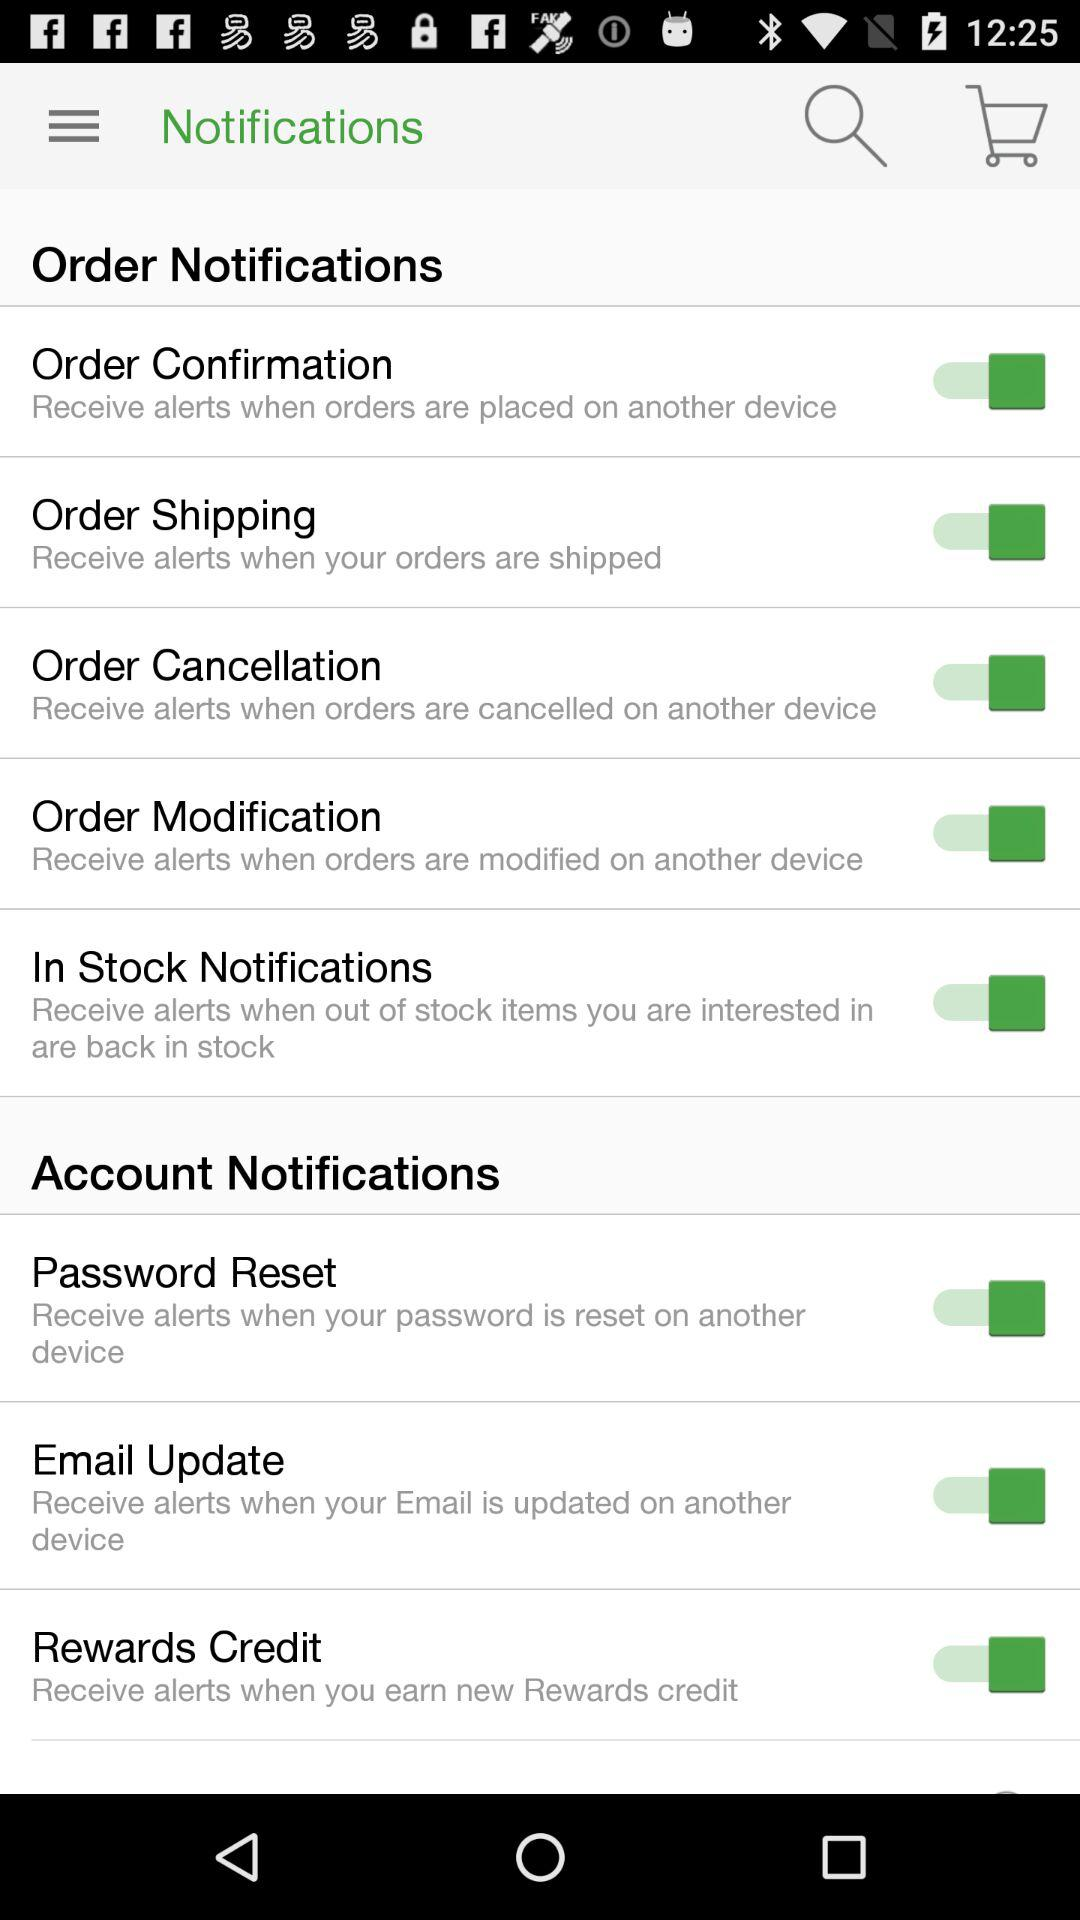Which notifications are switched on? The notifications that are switched on are "Order Confirmation", "Order Shipping", "Order Cancellation", "Order Modification", "In Stock Notifications", "Password Reset", "Email Update" and "Rewards Credit". 